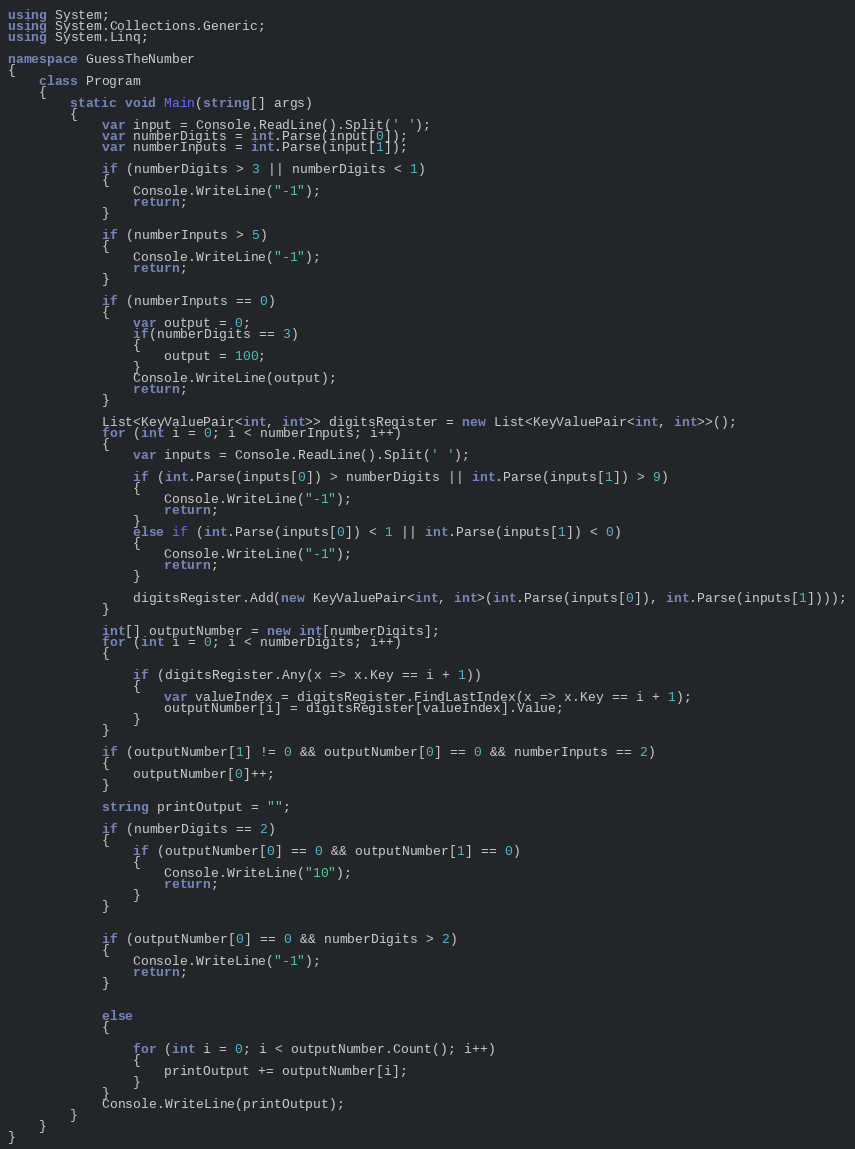Convert code to text. <code><loc_0><loc_0><loc_500><loc_500><_C#_>using System;
using System.Collections.Generic;
using System.Linq;

namespace GuessTheNumber
{
    class Program
    {
        static void Main(string[] args)
        {
            var input = Console.ReadLine().Split(' ');
            var numberDigits = int.Parse(input[0]);
            var numberInputs = int.Parse(input[1]);

            if (numberDigits > 3 || numberDigits < 1)
            {
                Console.WriteLine("-1");
                return;
            }

            if (numberInputs > 5)
            {
                Console.WriteLine("-1");
                return;
            }

            if (numberInputs == 0)
            {
                var output = 0;
                if(numberDigits == 3)
                {
                    output = 100;
                }                
                Console.WriteLine(output);
                return;
            }

            List<KeyValuePair<int, int>> digitsRegister = new List<KeyValuePair<int, int>>();
            for (int i = 0; i < numberInputs; i++)
            {
                var inputs = Console.ReadLine().Split(' ');

                if (int.Parse(inputs[0]) > numberDigits || int.Parse(inputs[1]) > 9)
                {
                    Console.WriteLine("-1");
                    return;
                }
                else if (int.Parse(inputs[0]) < 1 || int.Parse(inputs[1]) < 0)
                {
                    Console.WriteLine("-1");
                    return;
                }

                digitsRegister.Add(new KeyValuePair<int, int>(int.Parse(inputs[0]), int.Parse(inputs[1])));
            }

            int[] outputNumber = new int[numberDigits];
            for (int i = 0; i < numberDigits; i++)
            {

                if (digitsRegister.Any(x => x.Key == i + 1))
                {                    
                    var valueIndex = digitsRegister.FindLastIndex(x => x.Key == i + 1);
                    outputNumber[i] = digitsRegister[valueIndex].Value;
                }
            }

            if (outputNumber[1] != 0 && outputNumber[0] == 0 && numberInputs == 2)
            {
                outputNumber[0]++;
            }

            string printOutput = "";

            if (numberDigits == 2)
            {
                if (outputNumber[0] == 0 && outputNumber[1] == 0)
                {
                    Console.WriteLine("10");
                    return;
                }
            }


            if (outputNumber[0] == 0 && numberDigits > 2)
            {
                Console.WriteLine("-1");
                return;
            }

            
            else
            {

                for (int i = 0; i < outputNumber.Count(); i++)
                {
                    printOutput += outputNumber[i];
                }
            }
            Console.WriteLine(printOutput);
        }
    }
}
</code> 